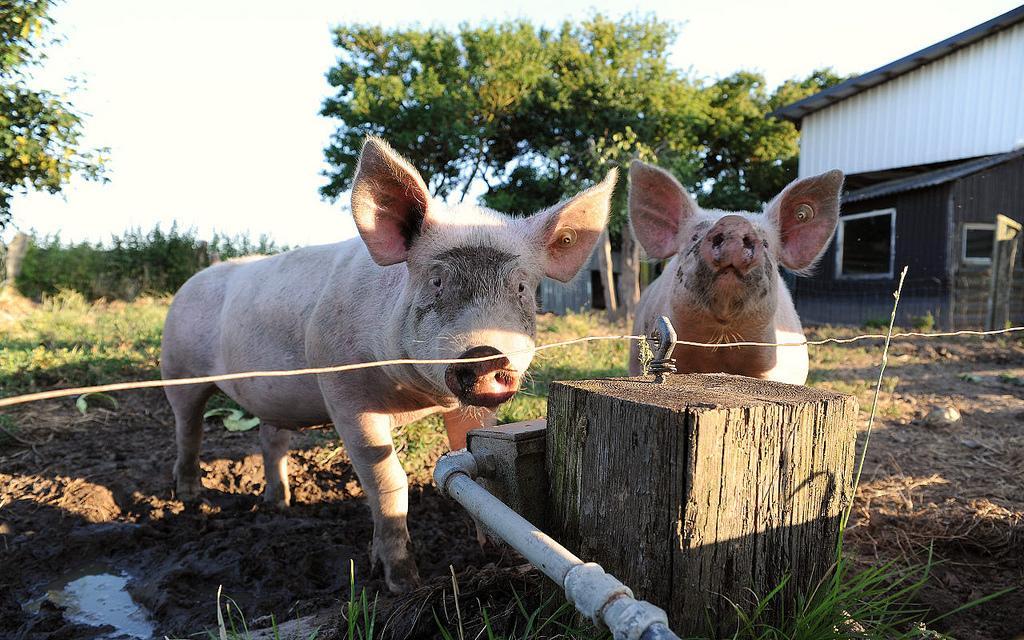Could you give a brief overview of what you see in this image? There are pigs, it seems like water pipe and wooden board in the foreground area of the image, there are trees, shed and the sky in the background. 